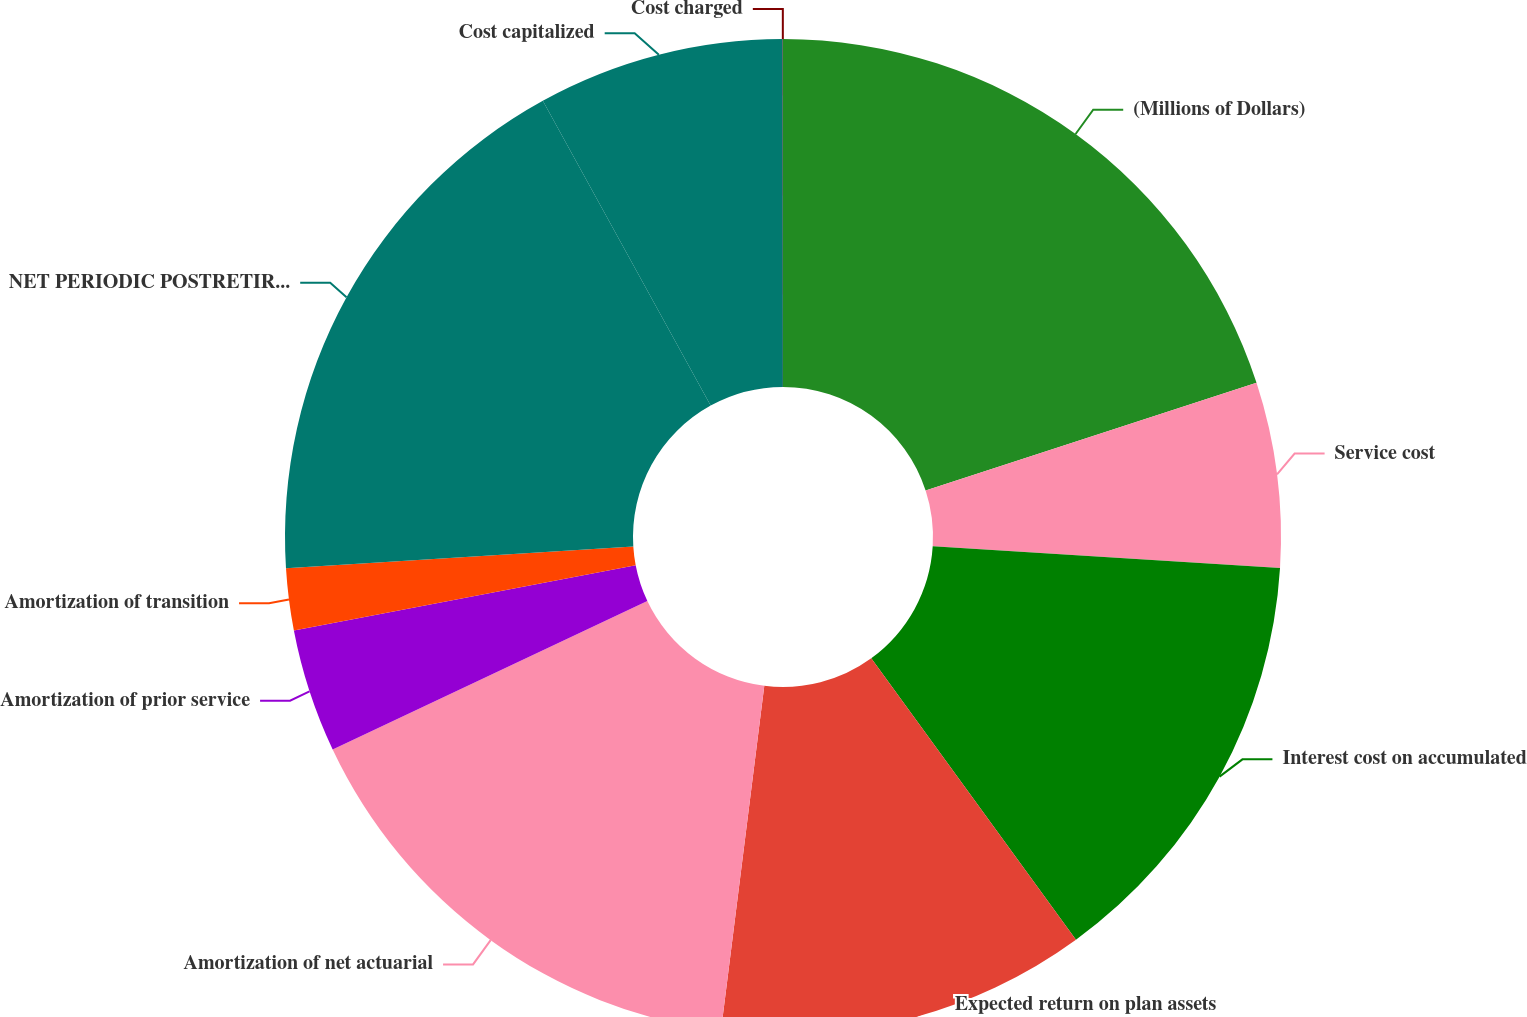<chart> <loc_0><loc_0><loc_500><loc_500><pie_chart><fcel>(Millions of Dollars)<fcel>Service cost<fcel>Interest cost on accumulated<fcel>Expected return on plan assets<fcel>Amortization of net actuarial<fcel>Amortization of prior service<fcel>Amortization of transition<fcel>NET PERIODIC POSTRETIREMENT<fcel>Cost capitalized<fcel>Cost charged<nl><fcel>19.99%<fcel>6.0%<fcel>14.0%<fcel>12.0%<fcel>15.99%<fcel>4.01%<fcel>2.01%<fcel>17.99%<fcel>8.0%<fcel>0.01%<nl></chart> 